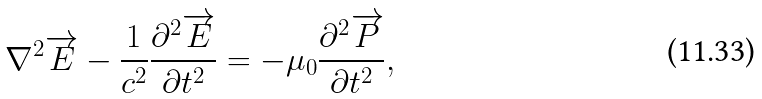<formula> <loc_0><loc_0><loc_500><loc_500>\nabla ^ { 2 } \overrightarrow { E } - \frac { 1 } { c ^ { 2 } } \frac { \partial ^ { 2 } \overrightarrow { E } } { \partial t ^ { 2 } } = - \mu _ { 0 } \frac { \partial ^ { 2 } \overrightarrow { P } } { \partial t ^ { 2 } } ,</formula> 